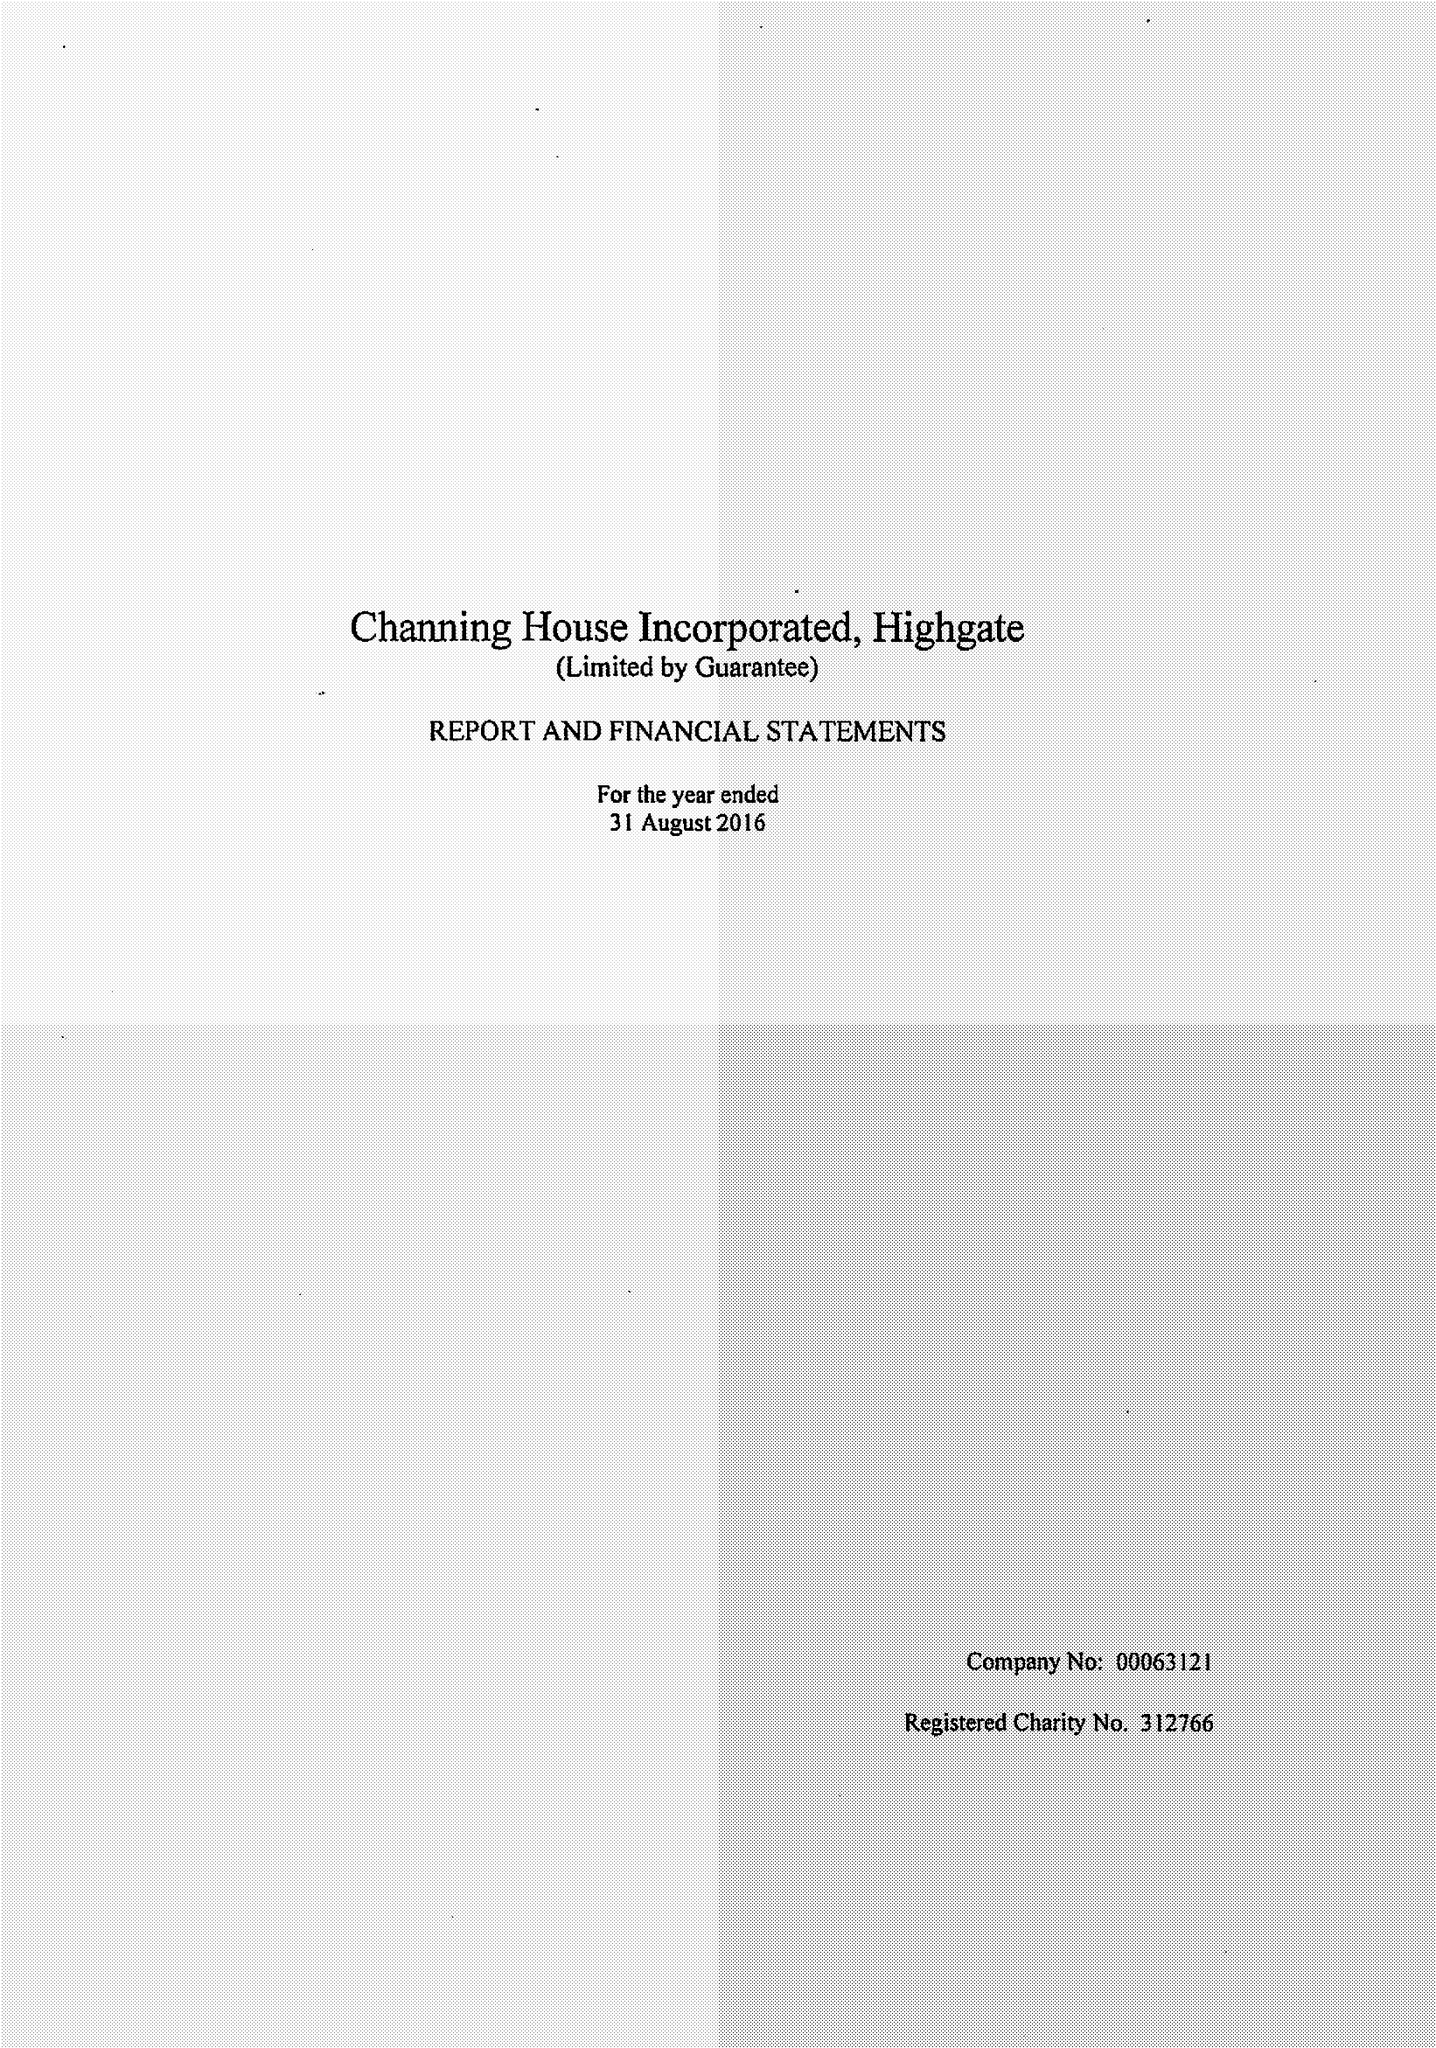What is the value for the income_annually_in_british_pounds?
Answer the question using a single word or phrase. 14260000.00 